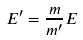<formula> <loc_0><loc_0><loc_500><loc_500>E ^ { \prime } = \frac { m } { m ^ { \prime } } E</formula> 